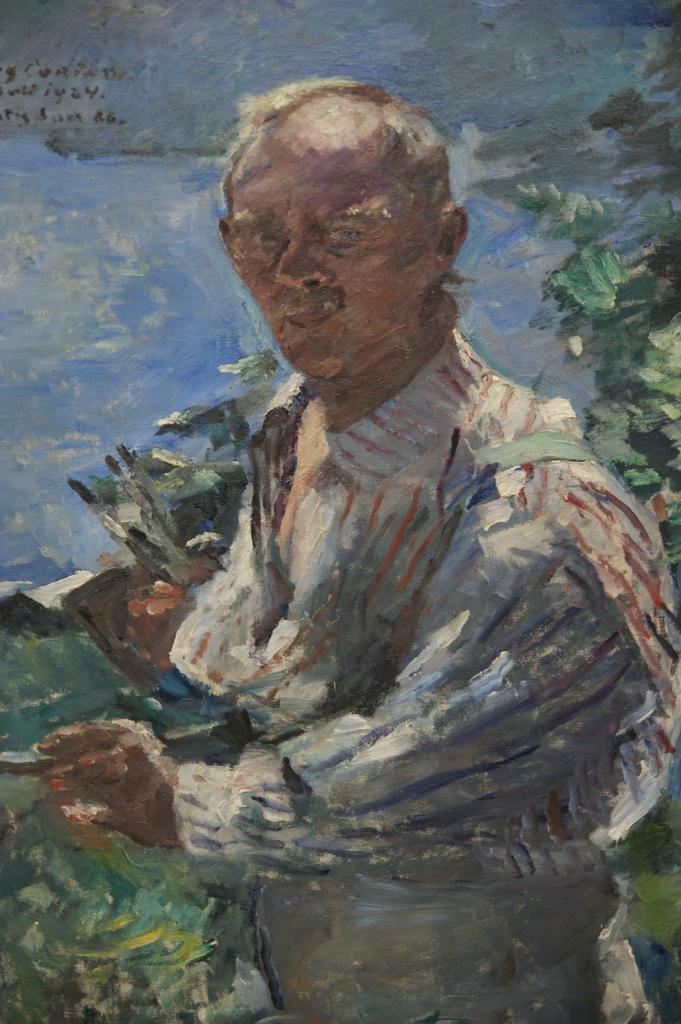What is the main subject of the painting in the image? The painting depicts a person holding an object. What is the person in the painting doing? The person is standing in the painting. What can be seen in the background of the painting? There are plants, trees, and water visible in the background of the painting. What type of crook can be seen riding a carriage in the painting? There is no crook or carriage present in the painting; it features a person holding an object and a background with plants, trees, and water. What shape is the circle that the person is holding in the painting? The painting does not depict a circle; it shows a person holding an unspecified object. 